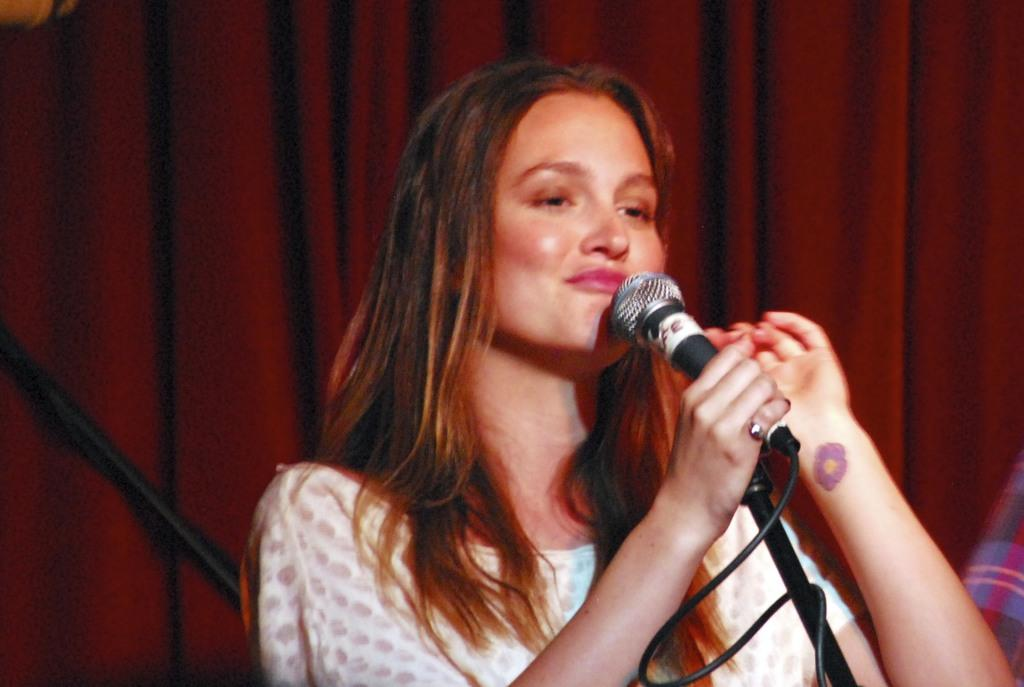Who is the main subject in the image? There is a woman in the image. Where is the woman positioned in the image? The woman is standing in the middle of the image. What is the woman holding in the image? The woman is holding a microphone. What can be seen behind the woman in the image? There is a curtain behind the woman. What type of jelly is being used to operate the machine in the image? There is no jelly or machine present in the image. How many fingers is the woman using to hold the microphone in the image? The image does not provide enough detail to determine the number of fingers the woman is using to hold the microphone. 